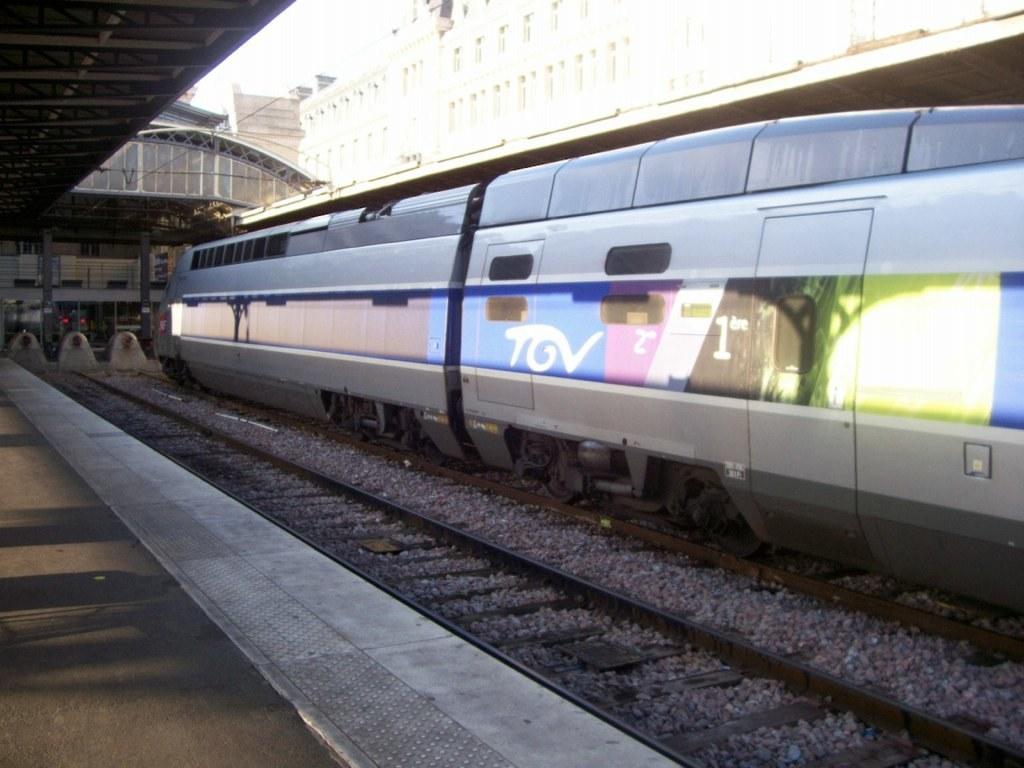What number train is this?
Your answer should be very brief. 1. What company operates this train?
Provide a short and direct response. Tov. 